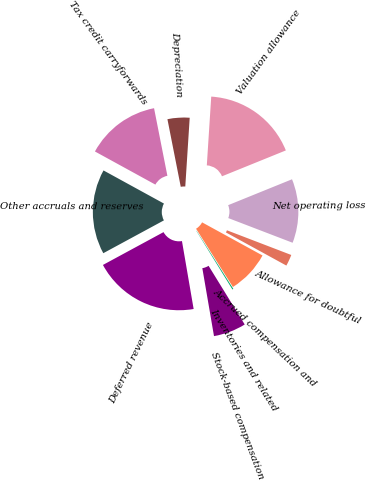<chart> <loc_0><loc_0><loc_500><loc_500><pie_chart><fcel>Net operating loss<fcel>Allowance for doubtful<fcel>Accrued compensation and<fcel>Inventories and related<fcel>Stock-based compensation<fcel>Deferred revenue<fcel>Other accruals and reserves<fcel>Tax credit carryforwards<fcel>Depreciation<fcel>Valuation allowance<nl><fcel>11.96%<fcel>2.15%<fcel>8.04%<fcel>0.19%<fcel>6.08%<fcel>19.81%<fcel>15.88%<fcel>13.92%<fcel>4.12%<fcel>17.85%<nl></chart> 